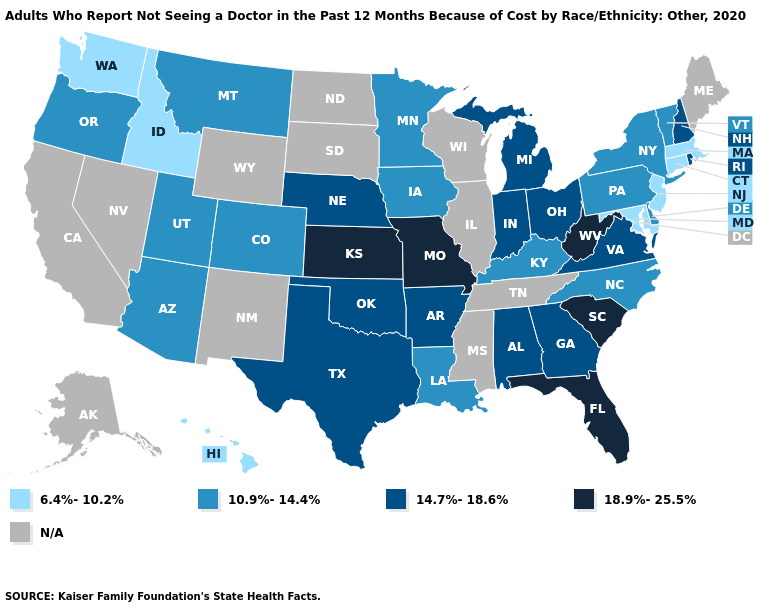Name the states that have a value in the range 18.9%-25.5%?
Give a very brief answer. Florida, Kansas, Missouri, South Carolina, West Virginia. Does the map have missing data?
Answer briefly. Yes. Does Maryland have the lowest value in the USA?
Give a very brief answer. Yes. What is the value of Wyoming?
Answer briefly. N/A. What is the value of Minnesota?
Write a very short answer. 10.9%-14.4%. What is the value of Rhode Island?
Give a very brief answer. 14.7%-18.6%. Name the states that have a value in the range 18.9%-25.5%?
Give a very brief answer. Florida, Kansas, Missouri, South Carolina, West Virginia. What is the value of Idaho?
Answer briefly. 6.4%-10.2%. What is the value of Washington?
Answer briefly. 6.4%-10.2%. Name the states that have a value in the range 6.4%-10.2%?
Answer briefly. Connecticut, Hawaii, Idaho, Maryland, Massachusetts, New Jersey, Washington. Among the states that border Louisiana , which have the highest value?
Short answer required. Arkansas, Texas. Does Idaho have the highest value in the West?
Concise answer only. No. What is the highest value in states that border South Carolina?
Keep it brief. 14.7%-18.6%. Among the states that border Illinois , which have the highest value?
Give a very brief answer. Missouri. 